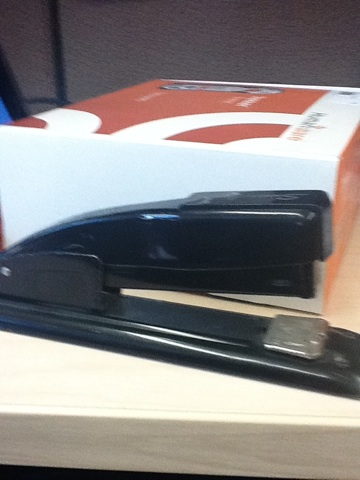This stapler looks quite sturdy. Is it suitable for heavy-duty stapling? This stapler appears to be a standard desktop model, which is typically used for regular office tasks like stapling up to 20 sheets of paper. For heavy-duty stapling, one might opt for a larger, more robust stapler designed to handle thicker stacks of paper. Could you give me a creative use for this stapler? Certainly! Imagine using a stapler as a tiny catapult for launching small paper projectiles in an office game. By placing a folded piece of paper on the end where staples come out and pressing down just enough to launch it, you could create a fun and competitive game with your co-workers, complete with targets and point systems! That sounds fun! What else can this stapler potentially be used for apart from stapling paper? Apart from its primary function of stapling paper, a stapler can be used creatively in various ways. For instance, it can be a temporary paperweight to keep papers from scattering. It can also be used as a nifty tool for securing small items like receipts or fabric swatches. Additionally, it can be a part of an improvised sculpture or art project, where its shiny, metallic parts add an interesting aesthetic. 